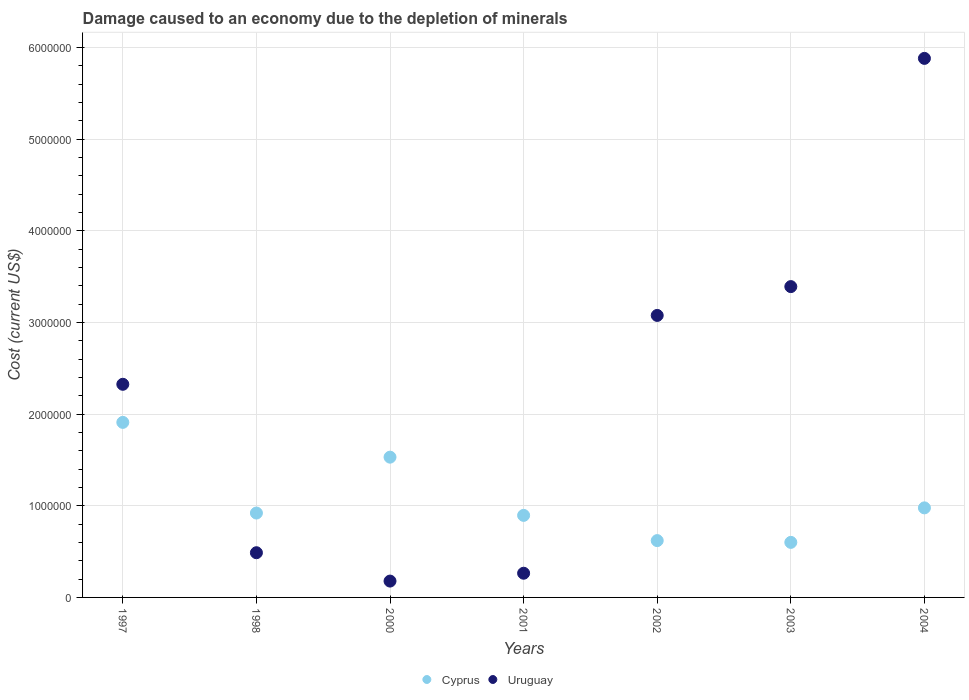What is the cost of damage caused due to the depletion of minerals in Uruguay in 2004?
Provide a short and direct response. 5.88e+06. Across all years, what is the maximum cost of damage caused due to the depletion of minerals in Cyprus?
Provide a short and direct response. 1.91e+06. Across all years, what is the minimum cost of damage caused due to the depletion of minerals in Uruguay?
Ensure brevity in your answer.  1.78e+05. What is the total cost of damage caused due to the depletion of minerals in Cyprus in the graph?
Your answer should be compact. 7.45e+06. What is the difference between the cost of damage caused due to the depletion of minerals in Cyprus in 2001 and that in 2004?
Your answer should be very brief. -8.19e+04. What is the difference between the cost of damage caused due to the depletion of minerals in Uruguay in 2002 and the cost of damage caused due to the depletion of minerals in Cyprus in 2003?
Offer a terse response. 2.48e+06. What is the average cost of damage caused due to the depletion of minerals in Uruguay per year?
Your response must be concise. 2.23e+06. In the year 2001, what is the difference between the cost of damage caused due to the depletion of minerals in Cyprus and cost of damage caused due to the depletion of minerals in Uruguay?
Offer a very short reply. 6.31e+05. What is the ratio of the cost of damage caused due to the depletion of minerals in Uruguay in 1998 to that in 2000?
Provide a succinct answer. 2.74. What is the difference between the highest and the second highest cost of damage caused due to the depletion of minerals in Uruguay?
Provide a succinct answer. 2.49e+06. What is the difference between the highest and the lowest cost of damage caused due to the depletion of minerals in Uruguay?
Keep it short and to the point. 5.70e+06. Is the cost of damage caused due to the depletion of minerals in Cyprus strictly less than the cost of damage caused due to the depletion of minerals in Uruguay over the years?
Provide a short and direct response. No. How many dotlines are there?
Provide a short and direct response. 2. How many years are there in the graph?
Your answer should be compact. 7. Are the values on the major ticks of Y-axis written in scientific E-notation?
Make the answer very short. No. How many legend labels are there?
Ensure brevity in your answer.  2. What is the title of the graph?
Keep it short and to the point. Damage caused to an economy due to the depletion of minerals. What is the label or title of the Y-axis?
Offer a terse response. Cost (current US$). What is the Cost (current US$) of Cyprus in 1997?
Offer a terse response. 1.91e+06. What is the Cost (current US$) in Uruguay in 1997?
Provide a short and direct response. 2.33e+06. What is the Cost (current US$) of Cyprus in 1998?
Keep it short and to the point. 9.21e+05. What is the Cost (current US$) of Uruguay in 1998?
Your answer should be compact. 4.88e+05. What is the Cost (current US$) in Cyprus in 2000?
Provide a short and direct response. 1.53e+06. What is the Cost (current US$) of Uruguay in 2000?
Make the answer very short. 1.78e+05. What is the Cost (current US$) of Cyprus in 2001?
Your answer should be very brief. 8.95e+05. What is the Cost (current US$) in Uruguay in 2001?
Offer a terse response. 2.64e+05. What is the Cost (current US$) of Cyprus in 2002?
Give a very brief answer. 6.20e+05. What is the Cost (current US$) in Uruguay in 2002?
Offer a very short reply. 3.08e+06. What is the Cost (current US$) in Cyprus in 2003?
Ensure brevity in your answer.  6.01e+05. What is the Cost (current US$) in Uruguay in 2003?
Give a very brief answer. 3.39e+06. What is the Cost (current US$) in Cyprus in 2004?
Offer a very short reply. 9.77e+05. What is the Cost (current US$) in Uruguay in 2004?
Keep it short and to the point. 5.88e+06. Across all years, what is the maximum Cost (current US$) of Cyprus?
Offer a very short reply. 1.91e+06. Across all years, what is the maximum Cost (current US$) of Uruguay?
Provide a succinct answer. 5.88e+06. Across all years, what is the minimum Cost (current US$) of Cyprus?
Your answer should be compact. 6.01e+05. Across all years, what is the minimum Cost (current US$) in Uruguay?
Give a very brief answer. 1.78e+05. What is the total Cost (current US$) in Cyprus in the graph?
Provide a succinct answer. 7.45e+06. What is the total Cost (current US$) of Uruguay in the graph?
Your answer should be compact. 1.56e+07. What is the difference between the Cost (current US$) in Cyprus in 1997 and that in 1998?
Offer a very short reply. 9.89e+05. What is the difference between the Cost (current US$) in Uruguay in 1997 and that in 1998?
Give a very brief answer. 1.84e+06. What is the difference between the Cost (current US$) in Cyprus in 1997 and that in 2000?
Ensure brevity in your answer.  3.79e+05. What is the difference between the Cost (current US$) of Uruguay in 1997 and that in 2000?
Make the answer very short. 2.15e+06. What is the difference between the Cost (current US$) in Cyprus in 1997 and that in 2001?
Keep it short and to the point. 1.01e+06. What is the difference between the Cost (current US$) in Uruguay in 1997 and that in 2001?
Provide a short and direct response. 2.06e+06. What is the difference between the Cost (current US$) of Cyprus in 1997 and that in 2002?
Keep it short and to the point. 1.29e+06. What is the difference between the Cost (current US$) of Uruguay in 1997 and that in 2002?
Provide a succinct answer. -7.51e+05. What is the difference between the Cost (current US$) in Cyprus in 1997 and that in 2003?
Make the answer very short. 1.31e+06. What is the difference between the Cost (current US$) in Uruguay in 1997 and that in 2003?
Keep it short and to the point. -1.07e+06. What is the difference between the Cost (current US$) of Cyprus in 1997 and that in 2004?
Ensure brevity in your answer.  9.33e+05. What is the difference between the Cost (current US$) in Uruguay in 1997 and that in 2004?
Offer a very short reply. -3.56e+06. What is the difference between the Cost (current US$) in Cyprus in 1998 and that in 2000?
Offer a very short reply. -6.10e+05. What is the difference between the Cost (current US$) of Uruguay in 1998 and that in 2000?
Provide a succinct answer. 3.09e+05. What is the difference between the Cost (current US$) of Cyprus in 1998 and that in 2001?
Give a very brief answer. 2.55e+04. What is the difference between the Cost (current US$) of Uruguay in 1998 and that in 2001?
Offer a very short reply. 2.24e+05. What is the difference between the Cost (current US$) of Cyprus in 1998 and that in 2002?
Keep it short and to the point. 3.01e+05. What is the difference between the Cost (current US$) in Uruguay in 1998 and that in 2002?
Ensure brevity in your answer.  -2.59e+06. What is the difference between the Cost (current US$) of Cyprus in 1998 and that in 2003?
Keep it short and to the point. 3.20e+05. What is the difference between the Cost (current US$) of Uruguay in 1998 and that in 2003?
Offer a terse response. -2.90e+06. What is the difference between the Cost (current US$) of Cyprus in 1998 and that in 2004?
Offer a terse response. -5.64e+04. What is the difference between the Cost (current US$) of Uruguay in 1998 and that in 2004?
Provide a succinct answer. -5.39e+06. What is the difference between the Cost (current US$) of Cyprus in 2000 and that in 2001?
Provide a short and direct response. 6.35e+05. What is the difference between the Cost (current US$) of Uruguay in 2000 and that in 2001?
Provide a short and direct response. -8.57e+04. What is the difference between the Cost (current US$) in Cyprus in 2000 and that in 2002?
Keep it short and to the point. 9.10e+05. What is the difference between the Cost (current US$) of Uruguay in 2000 and that in 2002?
Your answer should be compact. -2.90e+06. What is the difference between the Cost (current US$) in Cyprus in 2000 and that in 2003?
Offer a terse response. 9.30e+05. What is the difference between the Cost (current US$) in Uruguay in 2000 and that in 2003?
Offer a very short reply. -3.21e+06. What is the difference between the Cost (current US$) in Cyprus in 2000 and that in 2004?
Give a very brief answer. 5.53e+05. What is the difference between the Cost (current US$) of Uruguay in 2000 and that in 2004?
Provide a succinct answer. -5.70e+06. What is the difference between the Cost (current US$) of Cyprus in 2001 and that in 2002?
Give a very brief answer. 2.75e+05. What is the difference between the Cost (current US$) in Uruguay in 2001 and that in 2002?
Give a very brief answer. -2.81e+06. What is the difference between the Cost (current US$) of Cyprus in 2001 and that in 2003?
Keep it short and to the point. 2.95e+05. What is the difference between the Cost (current US$) in Uruguay in 2001 and that in 2003?
Keep it short and to the point. -3.13e+06. What is the difference between the Cost (current US$) of Cyprus in 2001 and that in 2004?
Ensure brevity in your answer.  -8.19e+04. What is the difference between the Cost (current US$) of Uruguay in 2001 and that in 2004?
Give a very brief answer. -5.62e+06. What is the difference between the Cost (current US$) in Cyprus in 2002 and that in 2003?
Your answer should be compact. 1.93e+04. What is the difference between the Cost (current US$) of Uruguay in 2002 and that in 2003?
Provide a short and direct response. -3.14e+05. What is the difference between the Cost (current US$) of Cyprus in 2002 and that in 2004?
Offer a very short reply. -3.57e+05. What is the difference between the Cost (current US$) in Uruguay in 2002 and that in 2004?
Make the answer very short. -2.80e+06. What is the difference between the Cost (current US$) in Cyprus in 2003 and that in 2004?
Your answer should be very brief. -3.77e+05. What is the difference between the Cost (current US$) in Uruguay in 2003 and that in 2004?
Offer a very short reply. -2.49e+06. What is the difference between the Cost (current US$) in Cyprus in 1997 and the Cost (current US$) in Uruguay in 1998?
Provide a short and direct response. 1.42e+06. What is the difference between the Cost (current US$) of Cyprus in 1997 and the Cost (current US$) of Uruguay in 2000?
Make the answer very short. 1.73e+06. What is the difference between the Cost (current US$) in Cyprus in 1997 and the Cost (current US$) in Uruguay in 2001?
Make the answer very short. 1.65e+06. What is the difference between the Cost (current US$) of Cyprus in 1997 and the Cost (current US$) of Uruguay in 2002?
Your response must be concise. -1.17e+06. What is the difference between the Cost (current US$) in Cyprus in 1997 and the Cost (current US$) in Uruguay in 2003?
Offer a terse response. -1.48e+06. What is the difference between the Cost (current US$) in Cyprus in 1997 and the Cost (current US$) in Uruguay in 2004?
Ensure brevity in your answer.  -3.97e+06. What is the difference between the Cost (current US$) in Cyprus in 1998 and the Cost (current US$) in Uruguay in 2000?
Offer a terse response. 7.42e+05. What is the difference between the Cost (current US$) of Cyprus in 1998 and the Cost (current US$) of Uruguay in 2001?
Keep it short and to the point. 6.57e+05. What is the difference between the Cost (current US$) of Cyprus in 1998 and the Cost (current US$) of Uruguay in 2002?
Make the answer very short. -2.16e+06. What is the difference between the Cost (current US$) of Cyprus in 1998 and the Cost (current US$) of Uruguay in 2003?
Make the answer very short. -2.47e+06. What is the difference between the Cost (current US$) of Cyprus in 1998 and the Cost (current US$) of Uruguay in 2004?
Provide a succinct answer. -4.96e+06. What is the difference between the Cost (current US$) of Cyprus in 2000 and the Cost (current US$) of Uruguay in 2001?
Give a very brief answer. 1.27e+06. What is the difference between the Cost (current US$) in Cyprus in 2000 and the Cost (current US$) in Uruguay in 2002?
Provide a short and direct response. -1.55e+06. What is the difference between the Cost (current US$) in Cyprus in 2000 and the Cost (current US$) in Uruguay in 2003?
Offer a terse response. -1.86e+06. What is the difference between the Cost (current US$) in Cyprus in 2000 and the Cost (current US$) in Uruguay in 2004?
Your response must be concise. -4.35e+06. What is the difference between the Cost (current US$) in Cyprus in 2001 and the Cost (current US$) in Uruguay in 2002?
Your response must be concise. -2.18e+06. What is the difference between the Cost (current US$) of Cyprus in 2001 and the Cost (current US$) of Uruguay in 2003?
Your response must be concise. -2.50e+06. What is the difference between the Cost (current US$) in Cyprus in 2001 and the Cost (current US$) in Uruguay in 2004?
Your answer should be compact. -4.99e+06. What is the difference between the Cost (current US$) of Cyprus in 2002 and the Cost (current US$) of Uruguay in 2003?
Your response must be concise. -2.77e+06. What is the difference between the Cost (current US$) in Cyprus in 2002 and the Cost (current US$) in Uruguay in 2004?
Ensure brevity in your answer.  -5.26e+06. What is the difference between the Cost (current US$) of Cyprus in 2003 and the Cost (current US$) of Uruguay in 2004?
Your answer should be compact. -5.28e+06. What is the average Cost (current US$) in Cyprus per year?
Your answer should be compact. 1.06e+06. What is the average Cost (current US$) in Uruguay per year?
Ensure brevity in your answer.  2.23e+06. In the year 1997, what is the difference between the Cost (current US$) in Cyprus and Cost (current US$) in Uruguay?
Your answer should be very brief. -4.16e+05. In the year 1998, what is the difference between the Cost (current US$) of Cyprus and Cost (current US$) of Uruguay?
Provide a succinct answer. 4.33e+05. In the year 2000, what is the difference between the Cost (current US$) of Cyprus and Cost (current US$) of Uruguay?
Give a very brief answer. 1.35e+06. In the year 2001, what is the difference between the Cost (current US$) of Cyprus and Cost (current US$) of Uruguay?
Offer a very short reply. 6.31e+05. In the year 2002, what is the difference between the Cost (current US$) in Cyprus and Cost (current US$) in Uruguay?
Provide a succinct answer. -2.46e+06. In the year 2003, what is the difference between the Cost (current US$) in Cyprus and Cost (current US$) in Uruguay?
Provide a succinct answer. -2.79e+06. In the year 2004, what is the difference between the Cost (current US$) in Cyprus and Cost (current US$) in Uruguay?
Make the answer very short. -4.90e+06. What is the ratio of the Cost (current US$) in Cyprus in 1997 to that in 1998?
Your response must be concise. 2.07. What is the ratio of the Cost (current US$) in Uruguay in 1997 to that in 1998?
Give a very brief answer. 4.77. What is the ratio of the Cost (current US$) in Cyprus in 1997 to that in 2000?
Give a very brief answer. 1.25. What is the ratio of the Cost (current US$) of Uruguay in 1997 to that in 2000?
Your answer should be very brief. 13.05. What is the ratio of the Cost (current US$) in Cyprus in 1997 to that in 2001?
Your answer should be very brief. 2.13. What is the ratio of the Cost (current US$) of Uruguay in 1997 to that in 2001?
Ensure brevity in your answer.  8.81. What is the ratio of the Cost (current US$) in Cyprus in 1997 to that in 2002?
Offer a terse response. 3.08. What is the ratio of the Cost (current US$) of Uruguay in 1997 to that in 2002?
Offer a terse response. 0.76. What is the ratio of the Cost (current US$) in Cyprus in 1997 to that in 2003?
Keep it short and to the point. 3.18. What is the ratio of the Cost (current US$) of Uruguay in 1997 to that in 2003?
Keep it short and to the point. 0.69. What is the ratio of the Cost (current US$) of Cyprus in 1997 to that in 2004?
Give a very brief answer. 1.95. What is the ratio of the Cost (current US$) of Uruguay in 1997 to that in 2004?
Provide a short and direct response. 0.4. What is the ratio of the Cost (current US$) in Cyprus in 1998 to that in 2000?
Your answer should be compact. 0.6. What is the ratio of the Cost (current US$) in Uruguay in 1998 to that in 2000?
Provide a succinct answer. 2.74. What is the ratio of the Cost (current US$) of Cyprus in 1998 to that in 2001?
Offer a terse response. 1.03. What is the ratio of the Cost (current US$) in Uruguay in 1998 to that in 2001?
Ensure brevity in your answer.  1.85. What is the ratio of the Cost (current US$) of Cyprus in 1998 to that in 2002?
Ensure brevity in your answer.  1.49. What is the ratio of the Cost (current US$) of Uruguay in 1998 to that in 2002?
Offer a terse response. 0.16. What is the ratio of the Cost (current US$) in Cyprus in 1998 to that in 2003?
Give a very brief answer. 1.53. What is the ratio of the Cost (current US$) of Uruguay in 1998 to that in 2003?
Provide a succinct answer. 0.14. What is the ratio of the Cost (current US$) of Cyprus in 1998 to that in 2004?
Provide a short and direct response. 0.94. What is the ratio of the Cost (current US$) in Uruguay in 1998 to that in 2004?
Offer a very short reply. 0.08. What is the ratio of the Cost (current US$) of Cyprus in 2000 to that in 2001?
Provide a short and direct response. 1.71. What is the ratio of the Cost (current US$) in Uruguay in 2000 to that in 2001?
Offer a terse response. 0.68. What is the ratio of the Cost (current US$) of Cyprus in 2000 to that in 2002?
Your response must be concise. 2.47. What is the ratio of the Cost (current US$) in Uruguay in 2000 to that in 2002?
Keep it short and to the point. 0.06. What is the ratio of the Cost (current US$) of Cyprus in 2000 to that in 2003?
Keep it short and to the point. 2.55. What is the ratio of the Cost (current US$) of Uruguay in 2000 to that in 2003?
Keep it short and to the point. 0.05. What is the ratio of the Cost (current US$) in Cyprus in 2000 to that in 2004?
Offer a very short reply. 1.57. What is the ratio of the Cost (current US$) of Uruguay in 2000 to that in 2004?
Give a very brief answer. 0.03. What is the ratio of the Cost (current US$) in Cyprus in 2001 to that in 2002?
Your answer should be very brief. 1.44. What is the ratio of the Cost (current US$) of Uruguay in 2001 to that in 2002?
Your answer should be very brief. 0.09. What is the ratio of the Cost (current US$) in Cyprus in 2001 to that in 2003?
Your answer should be compact. 1.49. What is the ratio of the Cost (current US$) in Uruguay in 2001 to that in 2003?
Your answer should be very brief. 0.08. What is the ratio of the Cost (current US$) of Cyprus in 2001 to that in 2004?
Make the answer very short. 0.92. What is the ratio of the Cost (current US$) of Uruguay in 2001 to that in 2004?
Offer a very short reply. 0.04. What is the ratio of the Cost (current US$) in Cyprus in 2002 to that in 2003?
Keep it short and to the point. 1.03. What is the ratio of the Cost (current US$) of Uruguay in 2002 to that in 2003?
Your response must be concise. 0.91. What is the ratio of the Cost (current US$) in Cyprus in 2002 to that in 2004?
Ensure brevity in your answer.  0.63. What is the ratio of the Cost (current US$) in Uruguay in 2002 to that in 2004?
Your response must be concise. 0.52. What is the ratio of the Cost (current US$) of Cyprus in 2003 to that in 2004?
Offer a very short reply. 0.61. What is the ratio of the Cost (current US$) in Uruguay in 2003 to that in 2004?
Your response must be concise. 0.58. What is the difference between the highest and the second highest Cost (current US$) of Cyprus?
Offer a terse response. 3.79e+05. What is the difference between the highest and the second highest Cost (current US$) of Uruguay?
Offer a terse response. 2.49e+06. What is the difference between the highest and the lowest Cost (current US$) of Cyprus?
Your answer should be very brief. 1.31e+06. What is the difference between the highest and the lowest Cost (current US$) of Uruguay?
Offer a very short reply. 5.70e+06. 